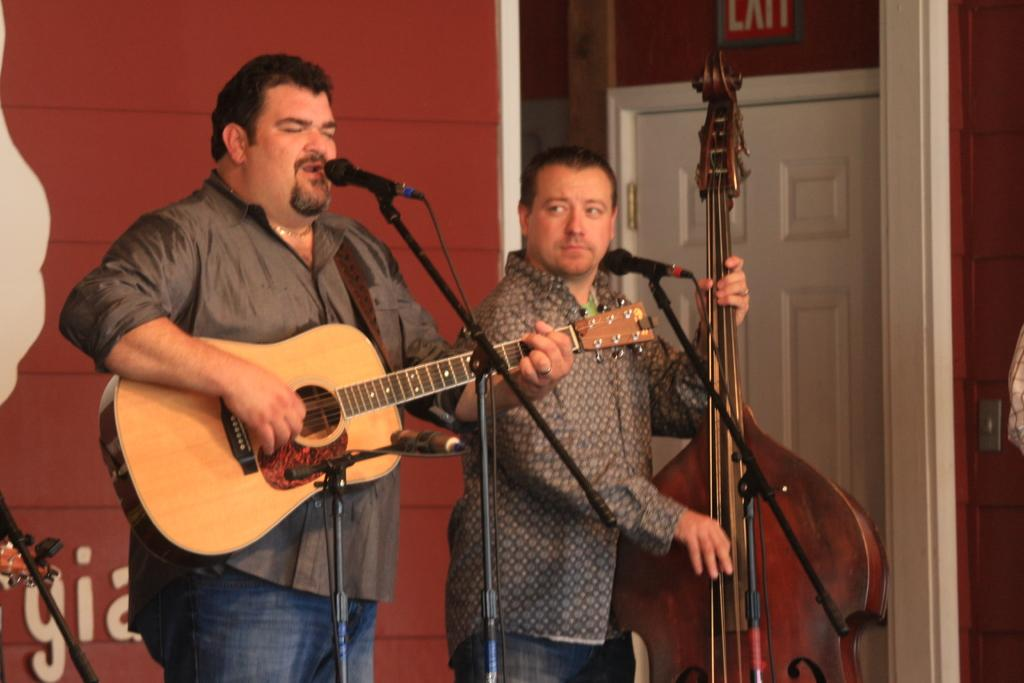What is the man in the image doing? The man is singing in the image. What is the man holding while singing? The man is holding a microphone. What musical instrument is the man playing? The man is playing a guitar. How many people are in the image? There are two people in the image. What is the second man playing in the image? The second man is playing a cello. What type of power does the man singing have in the image? There is no mention of power or any supernatural abilities in the image; the man is simply singing and playing a guitar. 